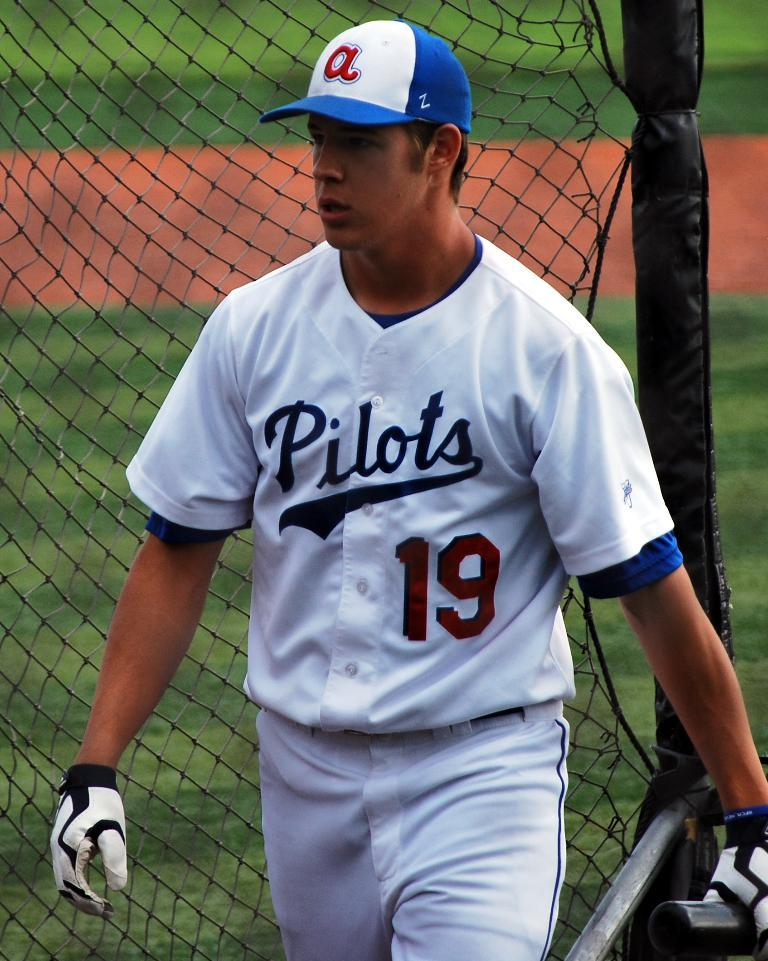<image>
Relay a brief, clear account of the picture shown. Number 19 of the Pilots baseball team with a bat by the cage 